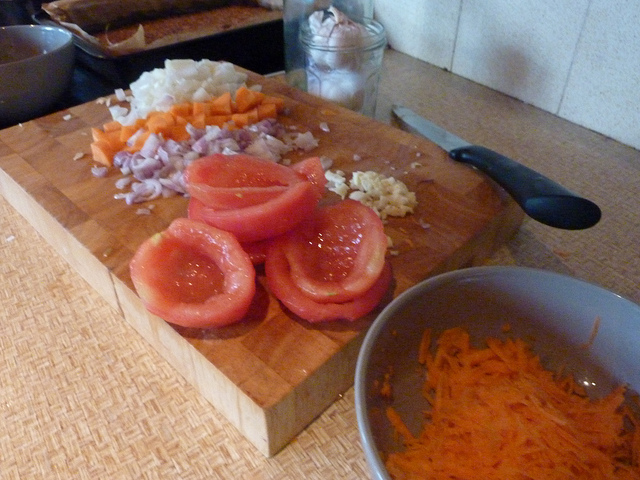<image>What's for lunch? I don't know what's for lunch. It could be stuffed tomatoes, pizza, salad, chopped vegetables, or tomatoes and carrots. What's for lunch? I don't know what's for lunch. It can be stuffed tomatoes, pizza, salad, chopped vegetables, tomatoes and carrots, or tomatoes and cheese. 